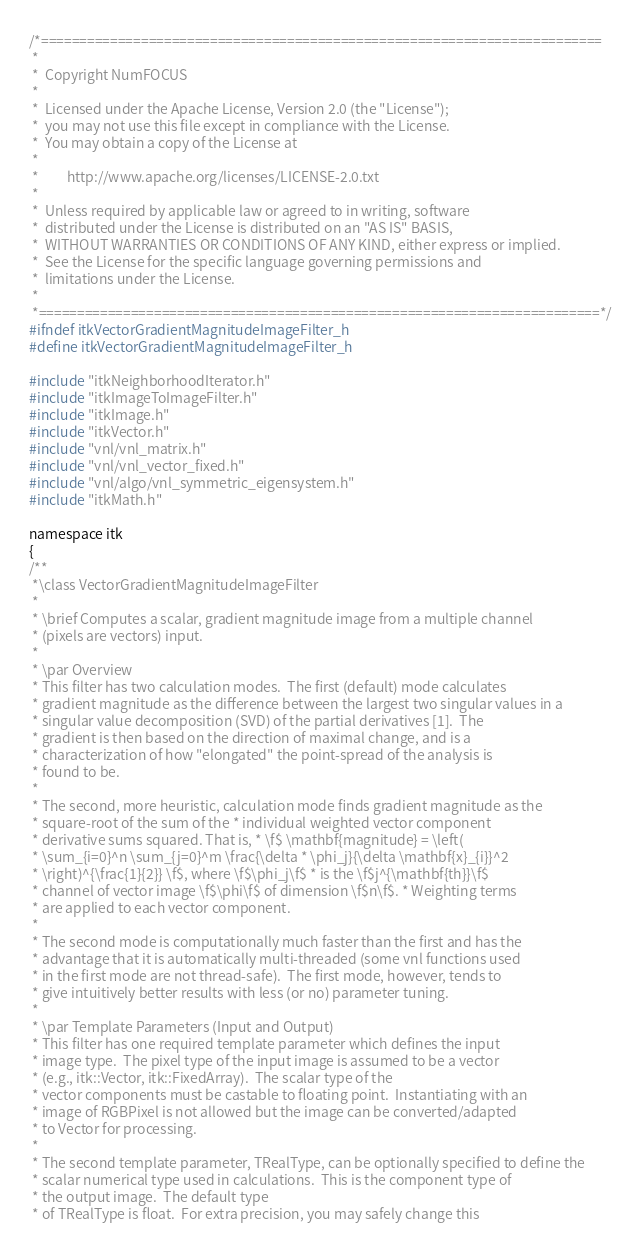Convert code to text. <code><loc_0><loc_0><loc_500><loc_500><_C_>/*=========================================================================
 *
 *  Copyright NumFOCUS
 *
 *  Licensed under the Apache License, Version 2.0 (the "License");
 *  you may not use this file except in compliance with the License.
 *  You may obtain a copy of the License at
 *
 *         http://www.apache.org/licenses/LICENSE-2.0.txt
 *
 *  Unless required by applicable law or agreed to in writing, software
 *  distributed under the License is distributed on an "AS IS" BASIS,
 *  WITHOUT WARRANTIES OR CONDITIONS OF ANY KIND, either express or implied.
 *  See the License for the specific language governing permissions and
 *  limitations under the License.
 *
 *=========================================================================*/
#ifndef itkVectorGradientMagnitudeImageFilter_h
#define itkVectorGradientMagnitudeImageFilter_h

#include "itkNeighborhoodIterator.h"
#include "itkImageToImageFilter.h"
#include "itkImage.h"
#include "itkVector.h"
#include "vnl/vnl_matrix.h"
#include "vnl/vnl_vector_fixed.h"
#include "vnl/algo/vnl_symmetric_eigensystem.h"
#include "itkMath.h"

namespace itk
{
/**
 *\class VectorGradientMagnitudeImageFilter
 *
 * \brief Computes a scalar, gradient magnitude image from a multiple channel
 * (pixels are vectors) input.
 *
 * \par Overview
 * This filter has two calculation modes.  The first (default) mode calculates
 * gradient magnitude as the difference between the largest two singular values in a
 * singular value decomposition (SVD) of the partial derivatives [1].  The
 * gradient is then based on the direction of maximal change, and is a
 * characterization of how "elongated" the point-spread of the analysis is
 * found to be.
 *
 * The second, more heuristic, calculation mode finds gradient magnitude as the
 * square-root of the sum of the * individual weighted vector component
 * derivative sums squared. That is, * \f$ \mathbf{magnitude} = \left(
 * \sum_{i=0}^n \sum_{j=0}^m \frac{\delta * \phi_j}{\delta \mathbf{x}_{i}}^2
 * \right)^{\frac{1}{2}} \f$, where \f$\phi_j\f$ * is the \f$j^{\mathbf{th}}\f$
 * channel of vector image \f$\phi\f$ of dimension \f$n\f$. * Weighting terms
 * are applied to each vector component.
 *
 * The second mode is computationally much faster than the first and has the
 * advantage that it is automatically multi-threaded (some vnl functions used
 * in the first mode are not thread-safe).  The first mode, however, tends to
 * give intuitively better results with less (or no) parameter tuning.
 *
 * \par Template Parameters (Input and Output)
 * This filter has one required template parameter which defines the input
 * image type.  The pixel type of the input image is assumed to be a vector
 * (e.g., itk::Vector, itk::FixedArray).  The scalar type of the
 * vector components must be castable to floating point.  Instantiating with an
 * image of RGBPixel is not allowed but the image can be converted/adapted
 * to Vector for processing.
 *
 * The second template parameter, TRealType, can be optionally specified to define the
 * scalar numerical type used in calculations.  This is the component type of
 * the output image.  The default type
 * of TRealType is float.  For extra precision, you may safely change this</code> 